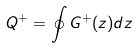Convert formula to latex. <formula><loc_0><loc_0><loc_500><loc_500>Q ^ { + } = \oint G ^ { + } ( z ) d z</formula> 